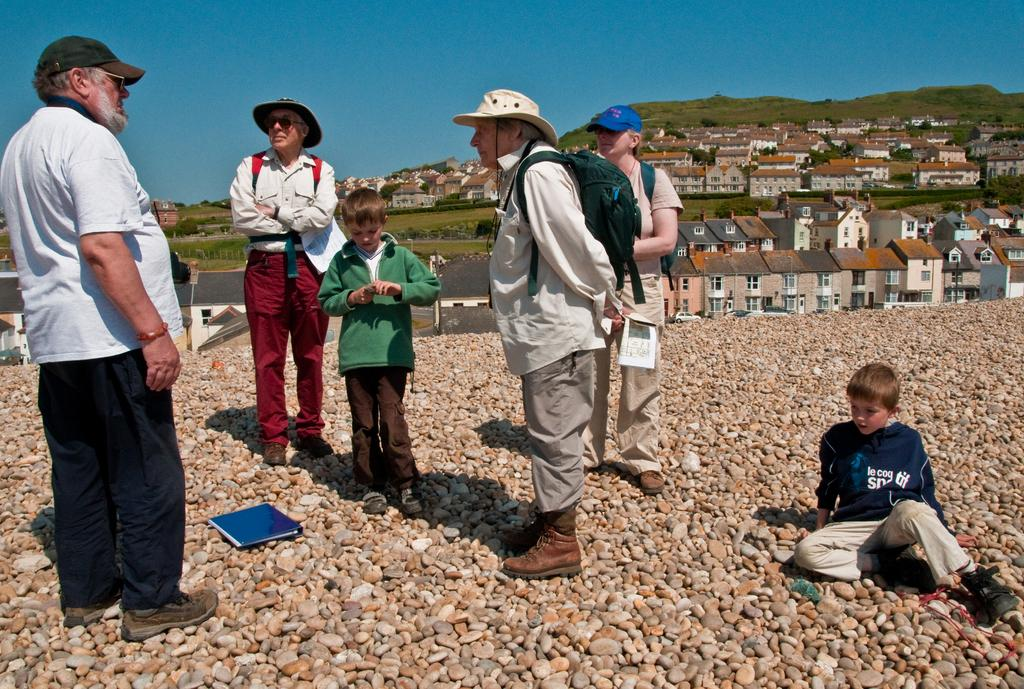What are the people in the image doing? The people in the image are standing on stones. What object can be seen in addition to the people and stones? There is a book visible in the image. What type of structures can be seen in the image? There are buildings with windows in the image. What natural feature is visible in the image? There are mountains in the image. What is visible in the background of the image? The sky is visible in the background of the image. What type of coal is being used to fuel the wren in the image? There is no wren or coal present in the image. What time of day is it in the image, considering the afternoon? The time of day cannot be determined from the image, as there is no indication of the time. 